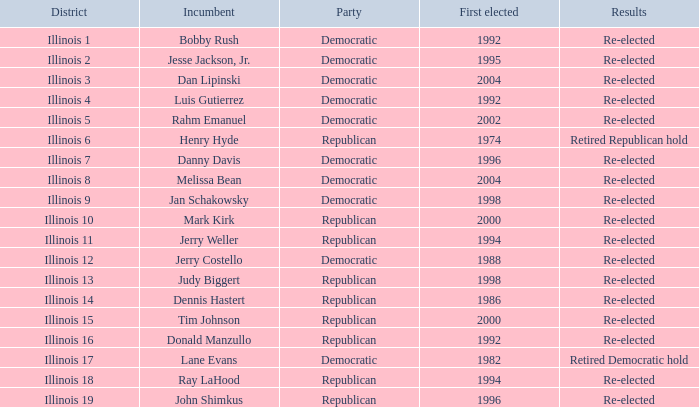What is the Party of District of Illinois 19 with an Incumbent First elected in 1996? Republican. 